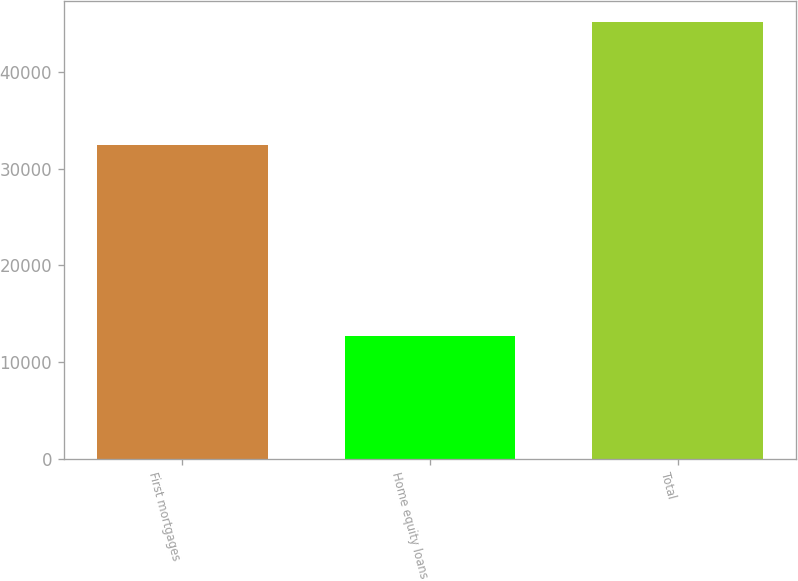Convert chart to OTSL. <chart><loc_0><loc_0><loc_500><loc_500><bar_chart><fcel>First mortgages<fcel>Home equity loans<fcel>Total<nl><fcel>32408<fcel>12698<fcel>45106<nl></chart> 